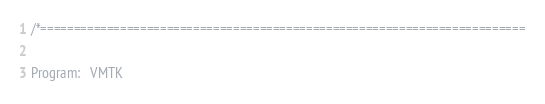Convert code to text. <code><loc_0><loc_0><loc_500><loc_500><_C++_>/*=========================================================================

Program:   VMTK</code> 